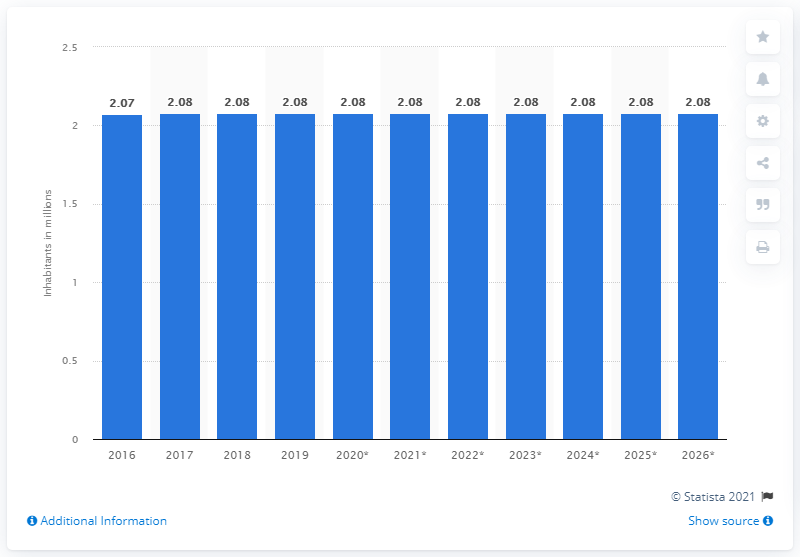Outline some significant characteristics in this image. The population of North Macedonia in 2019 was 2,080,000. 